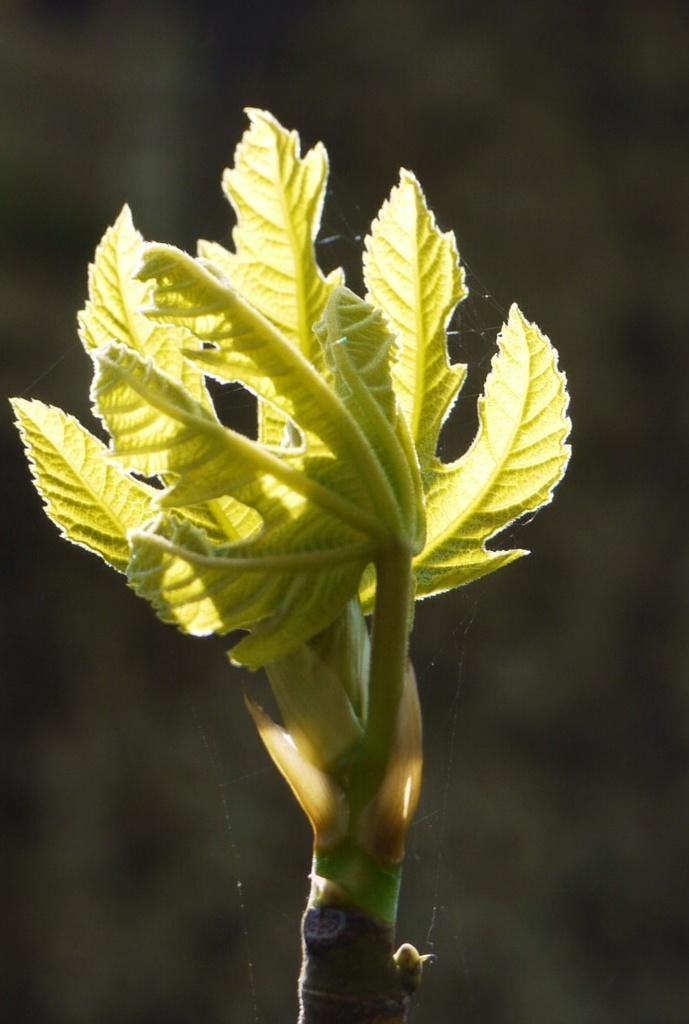Please provide a concise description of this image. This image consists of a plant. It is in green color. 